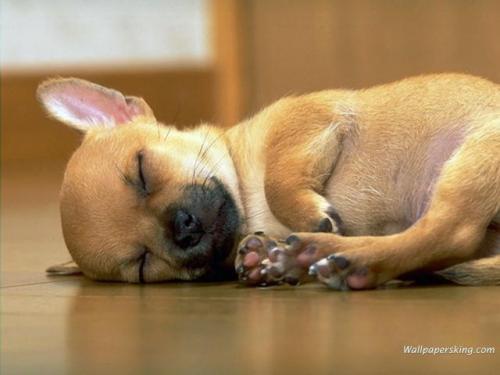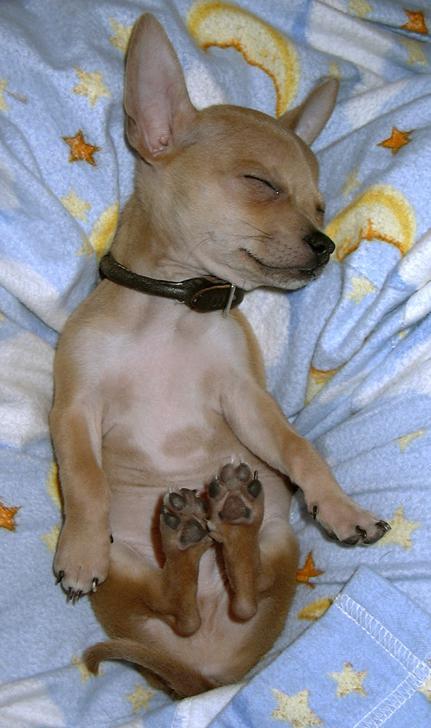The first image is the image on the left, the second image is the image on the right. Evaluate the accuracy of this statement regarding the images: "All chihuahuas appear to be sleeping, and one image contains twice as many chihuahuas as the other image.". Is it true? Answer yes or no. No. The first image is the image on the left, the second image is the image on the right. Assess this claim about the two images: "Three dogs are lying down sleeping.". Correct or not? Answer yes or no. No. 